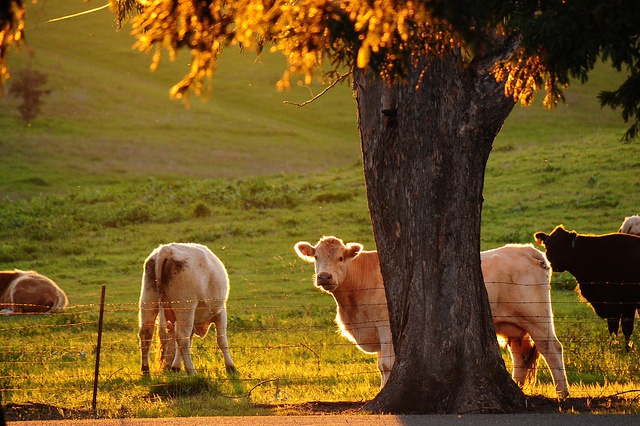Describe the objects in this image and their specific colors. I can see cow in black, brown, gray, and maroon tones, cow in black, brown, maroon, and gray tones, cow in black, maroon, orange, and brown tones, cow in black, maroon, and brown tones, and cow in black, gray, brown, and maroon tones in this image. 